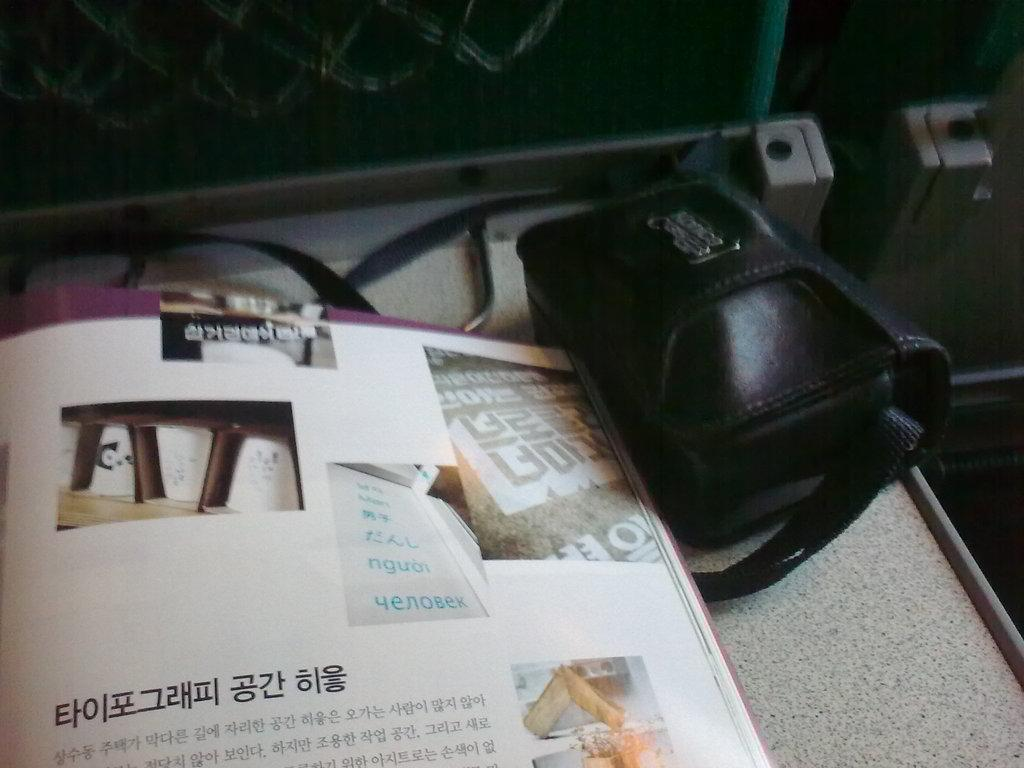What objects are on the table in the image? There are books and a black color bag on the table in the image. What can be seen inside the books? There is text visible in the book. How many fingers can be seen pointing at the boundary in the image? There are no fingers or boundaries present in the image. What type of vase is visible on the table in the image? There is no vase present in the image; it only contains books and a black color bag. 